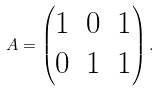Convert formula to latex. <formula><loc_0><loc_0><loc_500><loc_500>A = \begin{pmatrix} 1 & 0 & 1 \\ 0 & 1 & 1 \end{pmatrix} .</formula> 